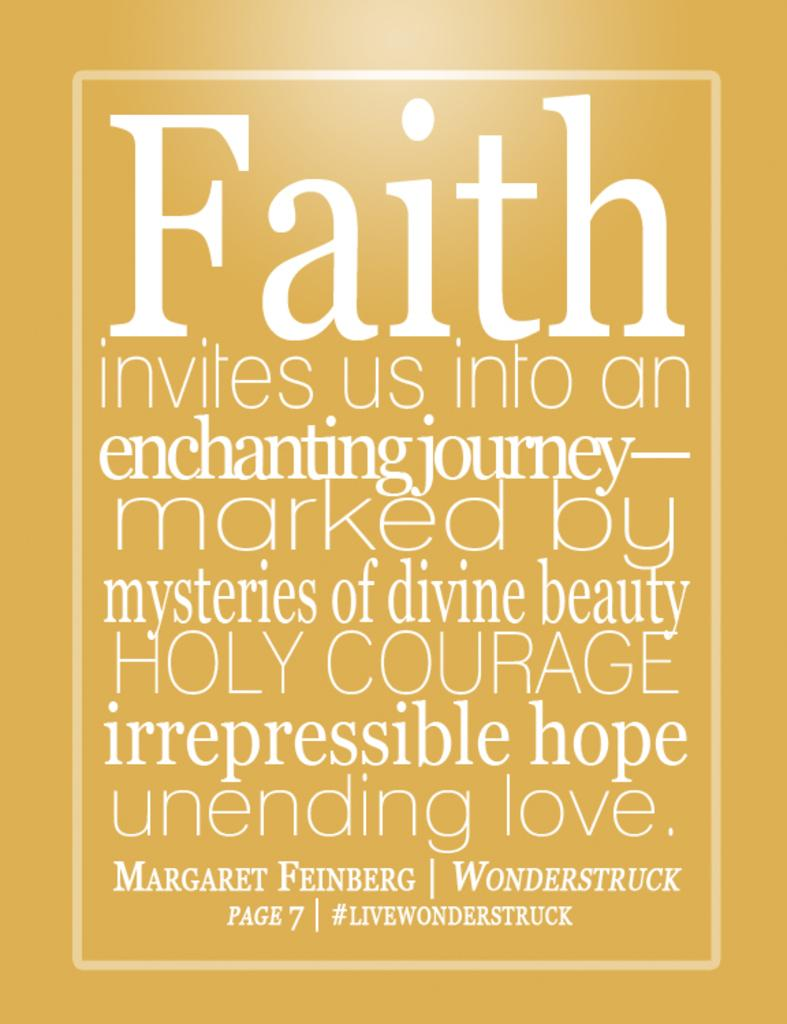<image>
Provide a brief description of the given image. A big poster that is yellowish and talks about faith. 